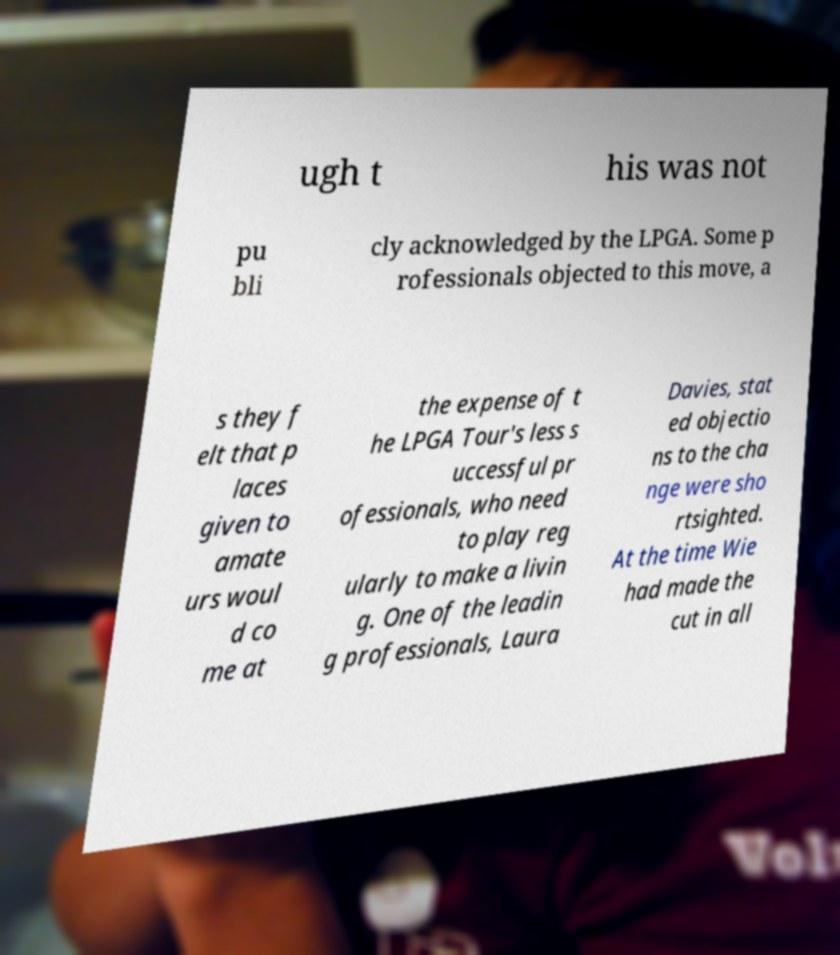Please read and relay the text visible in this image. What does it say? ugh t his was not pu bli cly acknowledged by the LPGA. Some p rofessionals objected to this move, a s they f elt that p laces given to amate urs woul d co me at the expense of t he LPGA Tour's less s uccessful pr ofessionals, who need to play reg ularly to make a livin g. One of the leadin g professionals, Laura Davies, stat ed objectio ns to the cha nge were sho rtsighted. At the time Wie had made the cut in all 